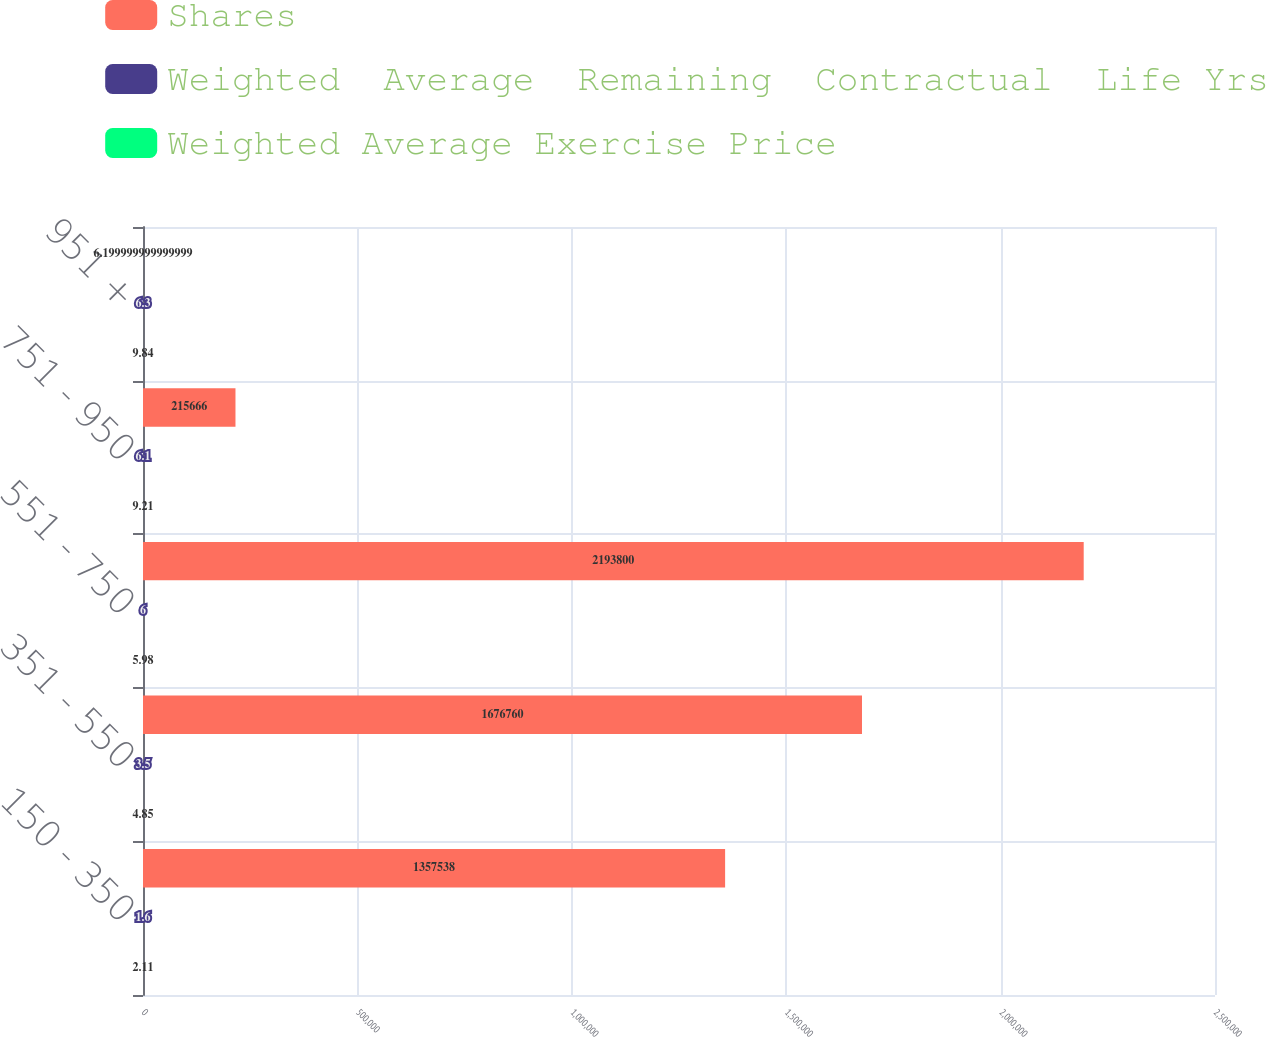<chart> <loc_0><loc_0><loc_500><loc_500><stacked_bar_chart><ecel><fcel>150 - 350<fcel>351 - 550<fcel>551 - 750<fcel>751 - 950<fcel>951 +<nl><fcel>Shares<fcel>1.35754e+06<fcel>1.67676e+06<fcel>2.1938e+06<fcel>215666<fcel>6.2<nl><fcel>Weighted  Average  Remaining  Contractual  Life Yrs<fcel>1.6<fcel>3.5<fcel>6<fcel>6.1<fcel>6.3<nl><fcel>Weighted Average Exercise Price<fcel>2.11<fcel>4.85<fcel>5.98<fcel>9.21<fcel>9.84<nl></chart> 